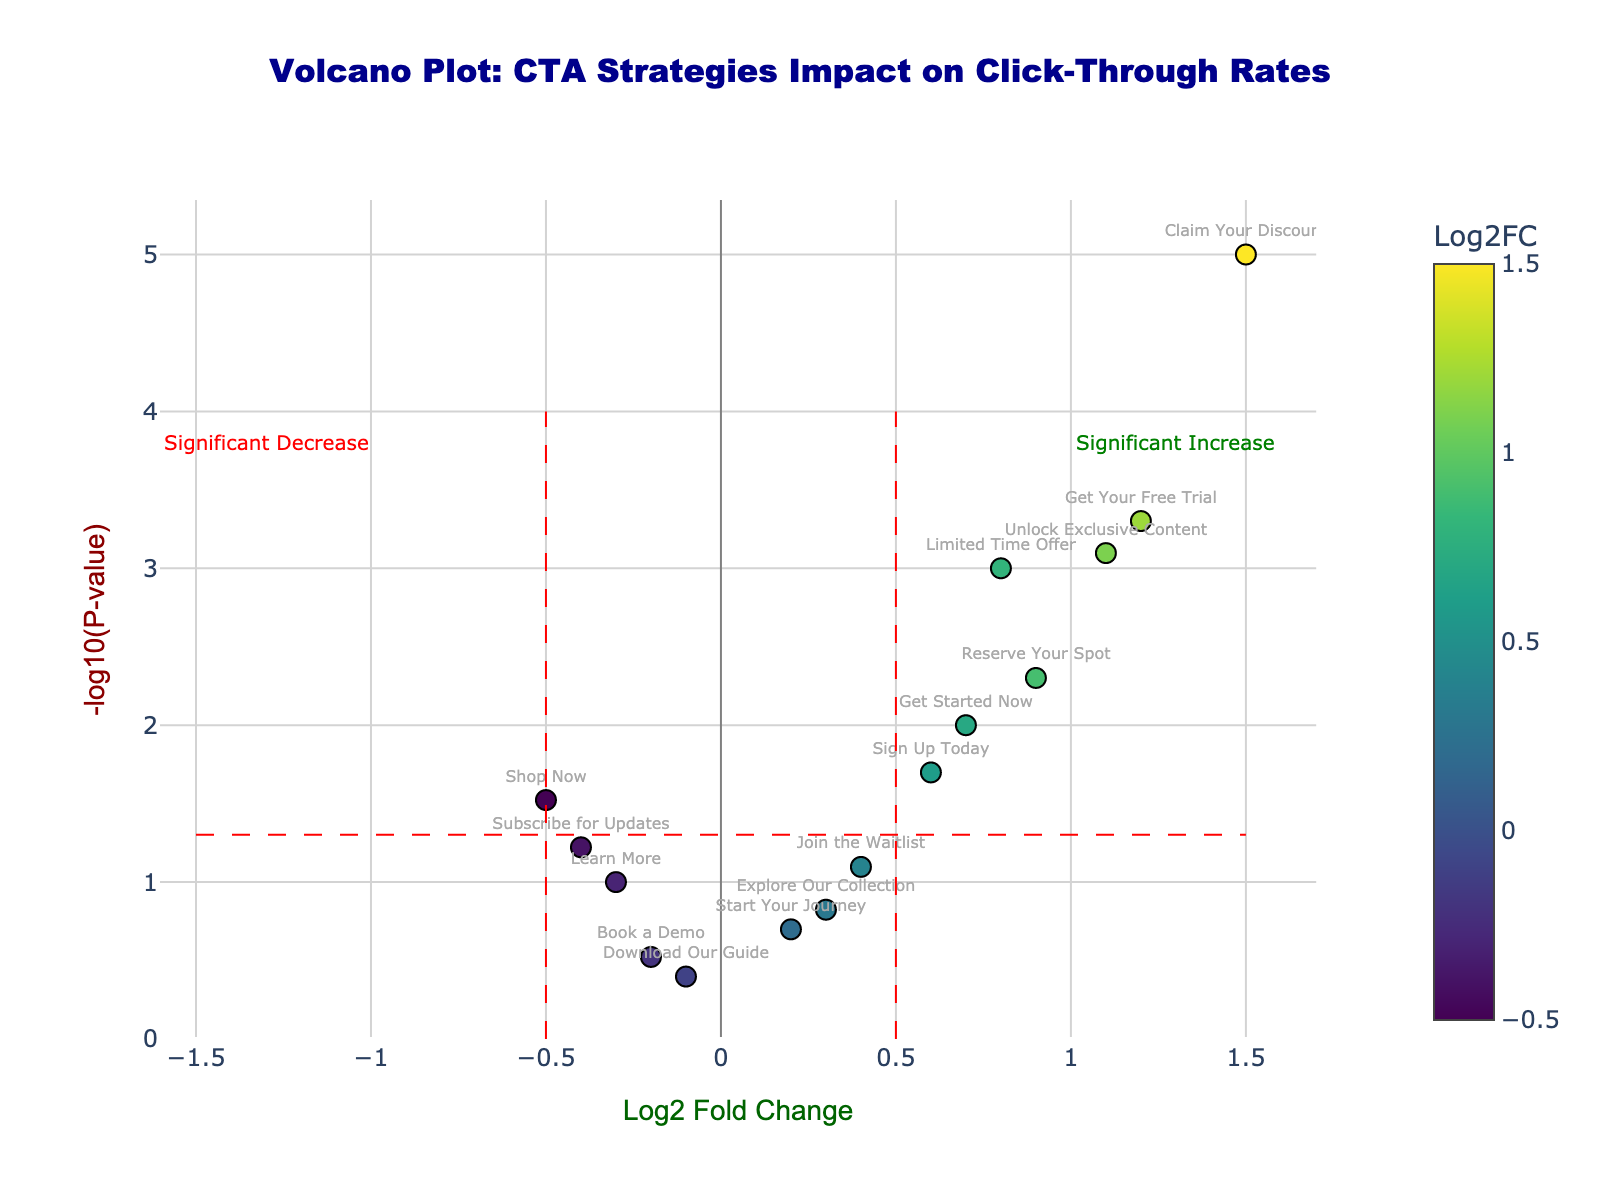What is the title of the figure? The title is located at the top center of the figure.
Answer: Volcano Plot: CTA Strategies Impact on Click-Through Rates Which CTA strategy has the highest log2 fold change? The highest log2 fold change can be found on the x-axis, where the CTA strategy "Claim Your Discount" is positioned furthest to the right.
Answer: Claim Your Discount How many CTA strategies show a statistically significant change in click-through rates (p-value < 0.05)? The horizontal red dashed line represents the p-value threshold of 0.05. Count the number of points above this line.
Answer: 8 Which CTA strategy shows the most significant increase in click-through rates? Look for the point with the highest log2 fold change (rightmost) and the smallest p-value (highest on the y-axis).
Answer: Claim Your Discount What is the log2 fold change of the "Get Your Free Trial" CTA strategy? Find the "Get Your Free Trial" CTA strategy on the chart and refer to its x-axis value.
Answer: 1.2 Which CTA strategies show a significant decrease in click-through rates? Check the points that are on the left side of the vertical red dashed line at -0.5 and above the horizontal red dashed line.
Answer: Shop Now, Subscribe for Updates What does the color scale in the plot represent? The color scale on the right side of the plot indicates the log2 fold change values.
Answer: Log2 fold change Among the CTA strategies with a log2 fold change above 1.0, which one has the lowest p-value? Compare the y-axis values of the strategies with log2 fold change above 1.0 and identify the highest point.
Answer: Claim Your Discount What is the -log10(p-value) threshold line drawn on the plot? The horizontal dashed red line represents the -log10(p-value) for a p-value of 0.05, which is -log10(0.05).
Answer: 1.301 Does the "Learn More" CTA strategy show a significant change in click-through rates? Verify if the "Learn More" CTA strategy is above or below the horizontal red dashed line.
Answer: No 